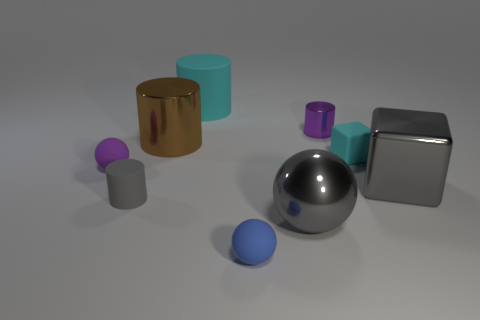Subtract all green cylinders. Subtract all yellow spheres. How many cylinders are left? 4 Add 1 gray rubber objects. How many objects exist? 10 Subtract all cubes. How many objects are left? 7 Add 1 cyan matte blocks. How many cyan matte blocks exist? 2 Subtract 0 cyan balls. How many objects are left? 9 Subtract all big gray balls. Subtract all blue objects. How many objects are left? 7 Add 9 gray metal spheres. How many gray metal spheres are left? 10 